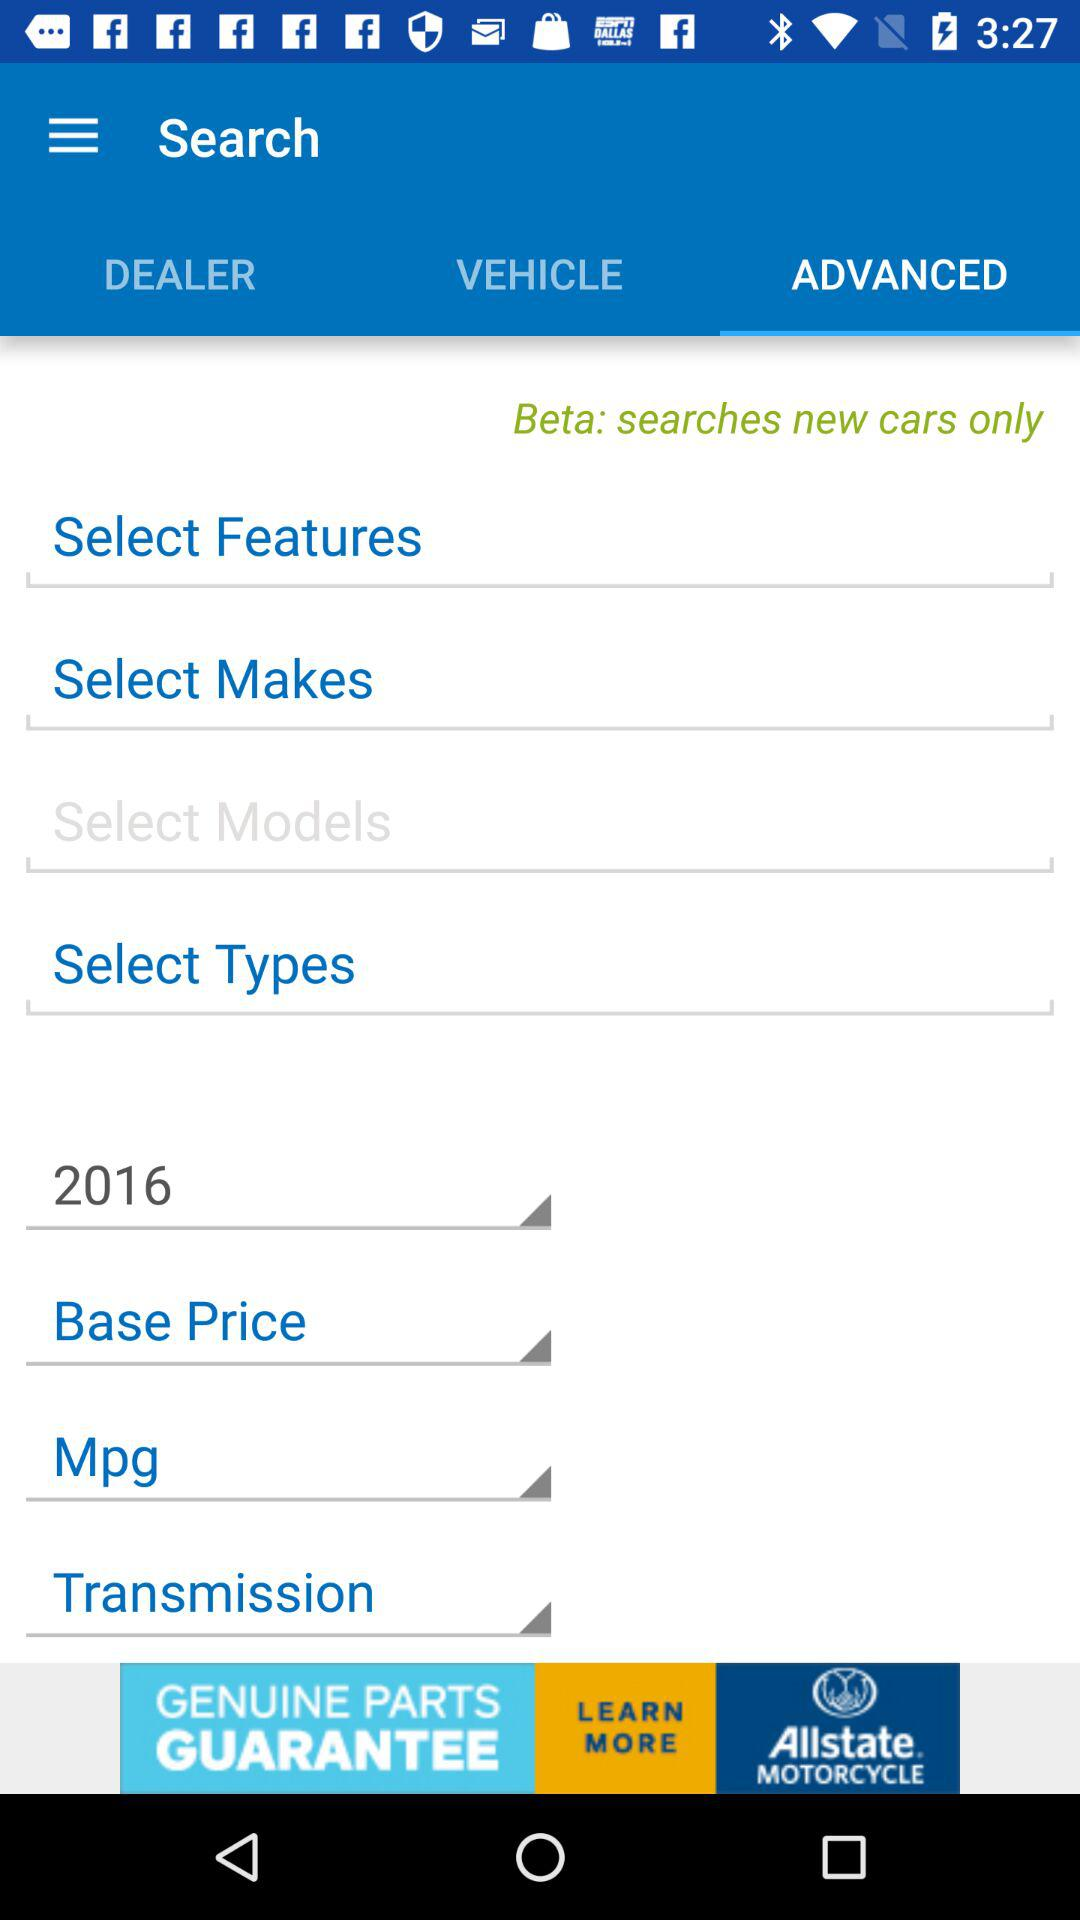Which tab is selected? The selected tab is "ADVANCED". 